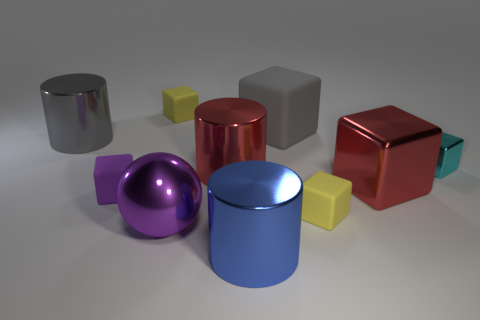How many tiny objects are either purple metal balls or cyan things?
Provide a short and direct response. 1. Is there anything else that is the same color as the small metallic cube?
Your answer should be very brief. No. Is the size of the yellow matte cube in front of the purple rubber object the same as the ball?
Make the answer very short. No. There is a large thing that is to the right of the yellow cube right of the yellow rubber thing that is behind the purple rubber block; what color is it?
Your response must be concise. Red. The big ball has what color?
Provide a short and direct response. Purple. Is the ball the same color as the large matte object?
Give a very brief answer. No. Does the tiny object on the right side of the big shiny cube have the same material as the yellow cube that is behind the big gray cylinder?
Provide a short and direct response. No. There is a blue thing that is the same shape as the large gray metal thing; what material is it?
Offer a terse response. Metal. Does the gray block have the same material as the purple block?
Ensure brevity in your answer.  Yes. There is a shiny block behind the big red block that is to the left of the cyan thing; what is its color?
Your answer should be compact. Cyan. 